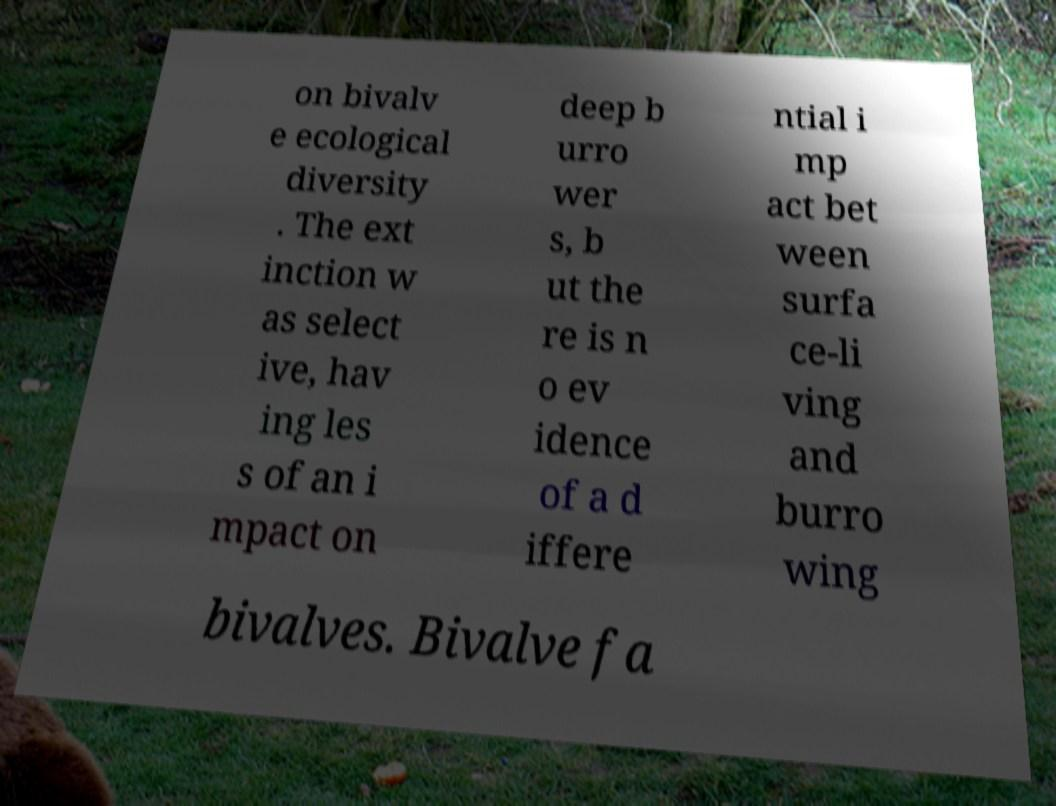Can you accurately transcribe the text from the provided image for me? on bivalv e ecological diversity . The ext inction w as select ive, hav ing les s of an i mpact on deep b urro wer s, b ut the re is n o ev idence of a d iffere ntial i mp act bet ween surfa ce-li ving and burro wing bivalves. Bivalve fa 